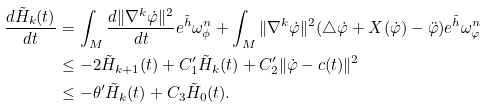Convert formula to latex. <formula><loc_0><loc_0><loc_500><loc_500>\frac { d \tilde { H } _ { k } ( t ) } { d t } & = \int _ { M } \frac { d \| \nabla ^ { k } \dot { \varphi } \| ^ { 2 } } { d t } e ^ { \tilde { h } } \omega _ { \phi } ^ { n } + \int _ { M } \| \nabla ^ { k } \dot { \varphi } \| ^ { 2 } ( \triangle \dot { \varphi } + X ( \dot { \varphi } ) - \ddot { \varphi } ) e ^ { \tilde { h } } \omega _ { \varphi } ^ { n } \\ & \leq - 2 \tilde { H } _ { k + 1 } ( t ) + C _ { 1 } ^ { \prime } \tilde { H } _ { k } ( t ) + C _ { 2 } ^ { \prime } \| \dot { \varphi } - c ( t ) \| ^ { 2 } \\ & \leq - \theta ^ { \prime } \tilde { H } _ { k } ( t ) + C _ { 3 } \tilde { H } _ { 0 } ( t ) .</formula> 